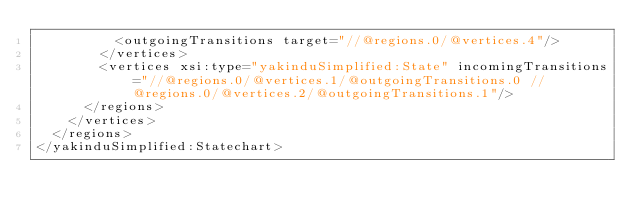<code> <loc_0><loc_0><loc_500><loc_500><_XML_>          <outgoingTransitions target="//@regions.0/@vertices.4"/>
        </vertices>
        <vertices xsi:type="yakinduSimplified:State" incomingTransitions="//@regions.0/@vertices.1/@outgoingTransitions.0 //@regions.0/@vertices.2/@outgoingTransitions.1"/>
      </regions>
    </vertices>
  </regions>
</yakinduSimplified:Statechart>
</code> 